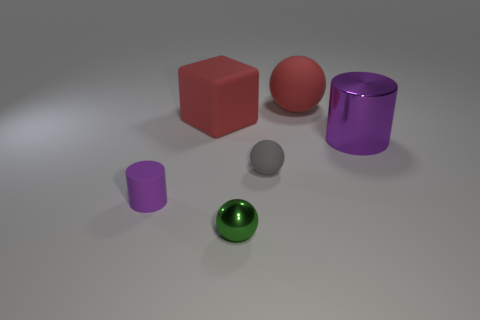Is there another tiny thing of the same shape as the small shiny object?
Give a very brief answer. Yes. Is the material of the small gray sphere the same as the ball in front of the gray matte thing?
Your answer should be compact. No. Are there any large objects of the same color as the big ball?
Offer a terse response. Yes. What number of other things are the same material as the tiny gray thing?
Give a very brief answer. 3. Is the color of the big cylinder the same as the small object on the left side of the small green object?
Provide a short and direct response. Yes. Are there more matte objects on the left side of the small matte ball than tiny green metallic objects?
Provide a short and direct response. Yes. How many large rubber things are left of the shiny object on the left side of the purple thing behind the small purple cylinder?
Your answer should be very brief. 1. There is a rubber thing to the left of the red cube; does it have the same shape as the big shiny thing?
Make the answer very short. Yes. There is a small ball on the right side of the metal sphere; what is it made of?
Your response must be concise. Rubber. There is a rubber object that is both behind the gray thing and on the right side of the small green metallic object; what shape is it?
Ensure brevity in your answer.  Sphere. 